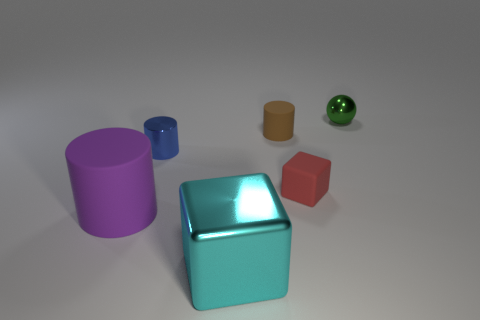There is a large thing that is to the left of the block in front of the tiny block; what is its material?
Ensure brevity in your answer.  Rubber. Are there any small red objects that have the same material as the tiny brown cylinder?
Your answer should be compact. Yes. There is a small shiny thing that is on the left side of the small green metal sphere; are there any purple rubber cylinders that are to the left of it?
Provide a succinct answer. Yes. What is the material of the brown cylinder to the left of the red cube?
Offer a terse response. Rubber. Is the red thing the same shape as the small brown matte thing?
Your response must be concise. No. The small cylinder in front of the cylinder that is right of the small metallic thing to the left of the tiny green metal thing is what color?
Give a very brief answer. Blue. How many small red matte things are the same shape as the big cyan metal object?
Provide a succinct answer. 1. There is a matte cylinder behind the block behind the purple thing; what size is it?
Provide a short and direct response. Small. Is the size of the cyan shiny cube the same as the red matte thing?
Your answer should be very brief. No. Are there any metal things that are in front of the cube that is in front of the tiny rubber object that is in front of the blue cylinder?
Give a very brief answer. No. 